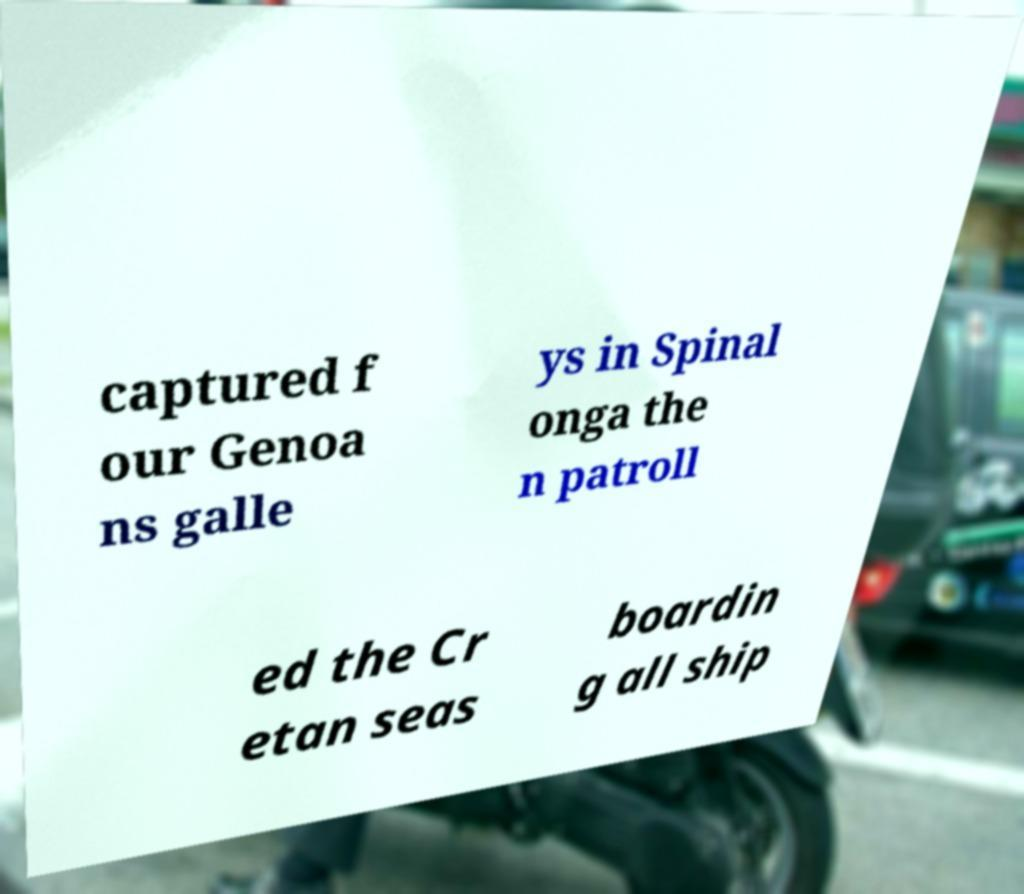For documentation purposes, I need the text within this image transcribed. Could you provide that? captured f our Genoa ns galle ys in Spinal onga the n patroll ed the Cr etan seas boardin g all ship 